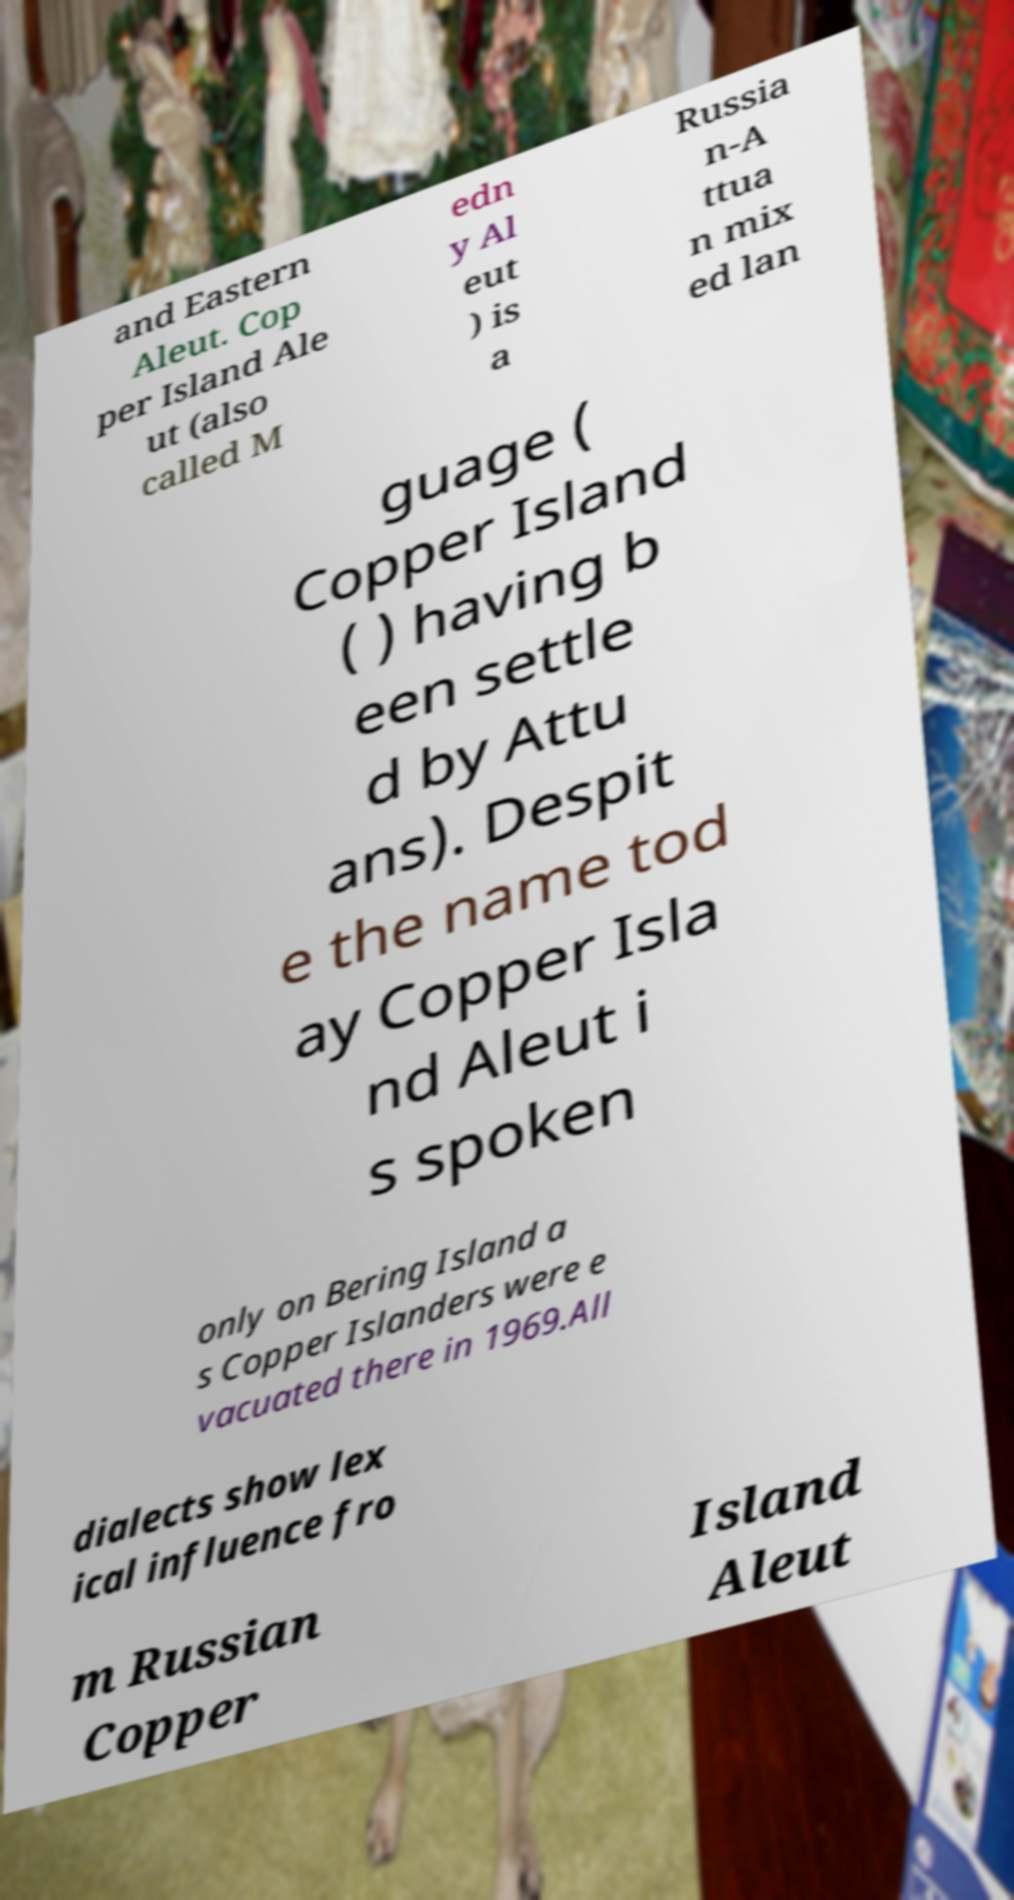Please read and relay the text visible in this image. What does it say? and Eastern Aleut. Cop per Island Ale ut (also called M edn y Al eut ) is a Russia n-A ttua n mix ed lan guage ( Copper Island ( ) having b een settle d by Attu ans). Despit e the name tod ay Copper Isla nd Aleut i s spoken only on Bering Island a s Copper Islanders were e vacuated there in 1969.All dialects show lex ical influence fro m Russian Copper Island Aleut 